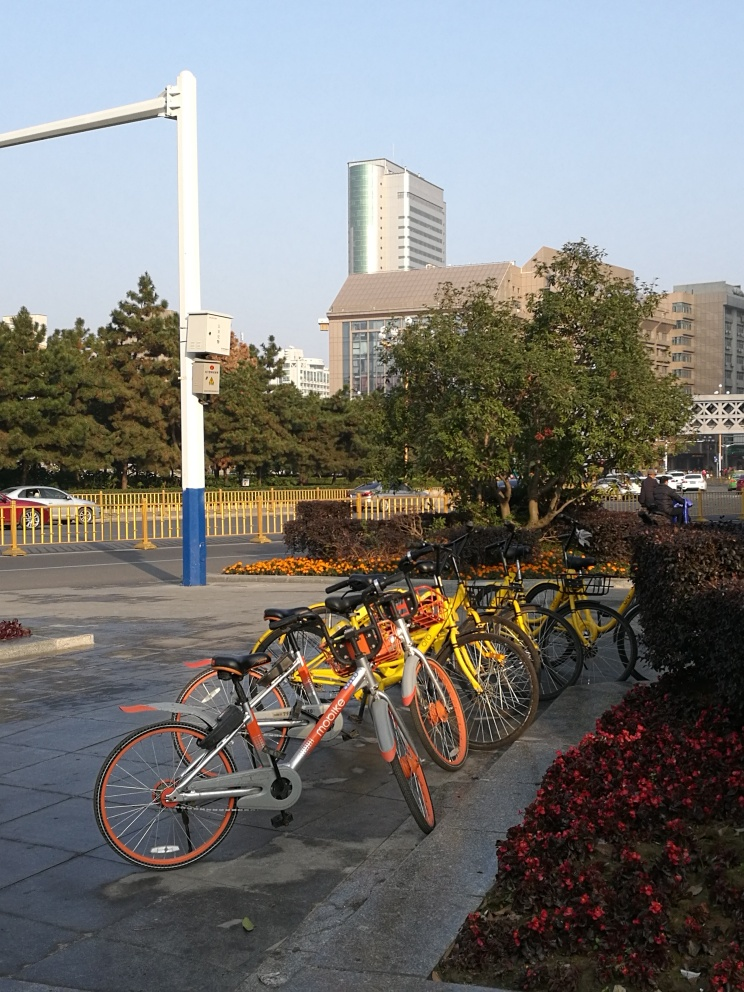What is the significance of the structure on the left side of the image? The structure on the left side appears to be a pole equipped with a box, likely an electrical control box or a traffic-related device given its proximity to the street. It is positioned to be easily accessible for maintenance yet does not encroach much on the pedestrian space. 